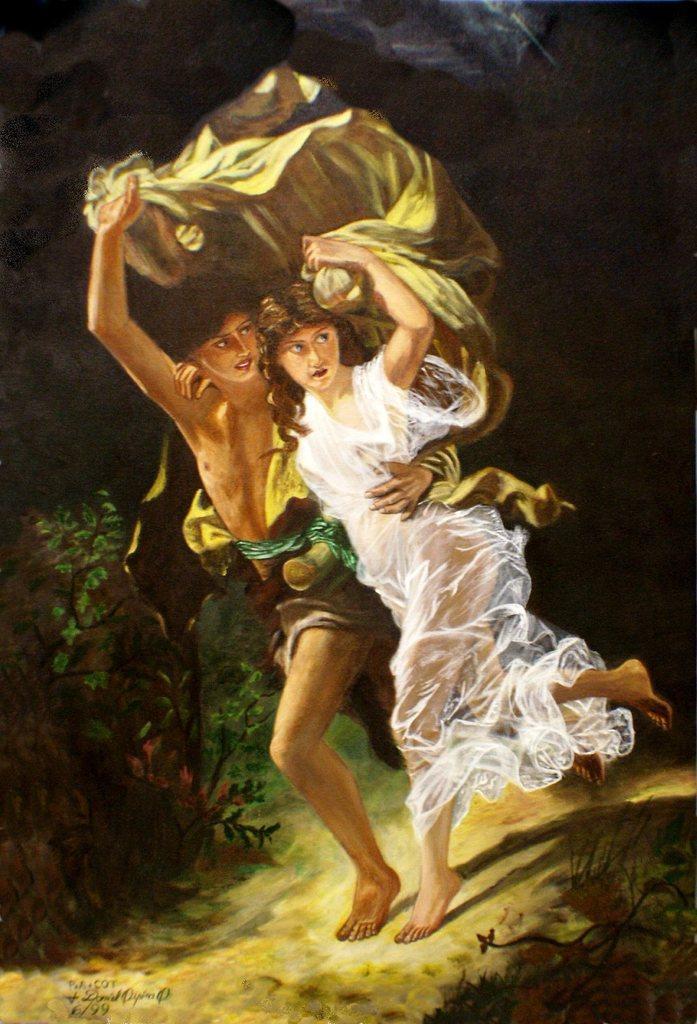In one or two sentences, can you explain what this image depicts? In this image I can see two people standing and holding something. They are wearing different color dresses. Background is in black and brown color. I can see few green plants. 